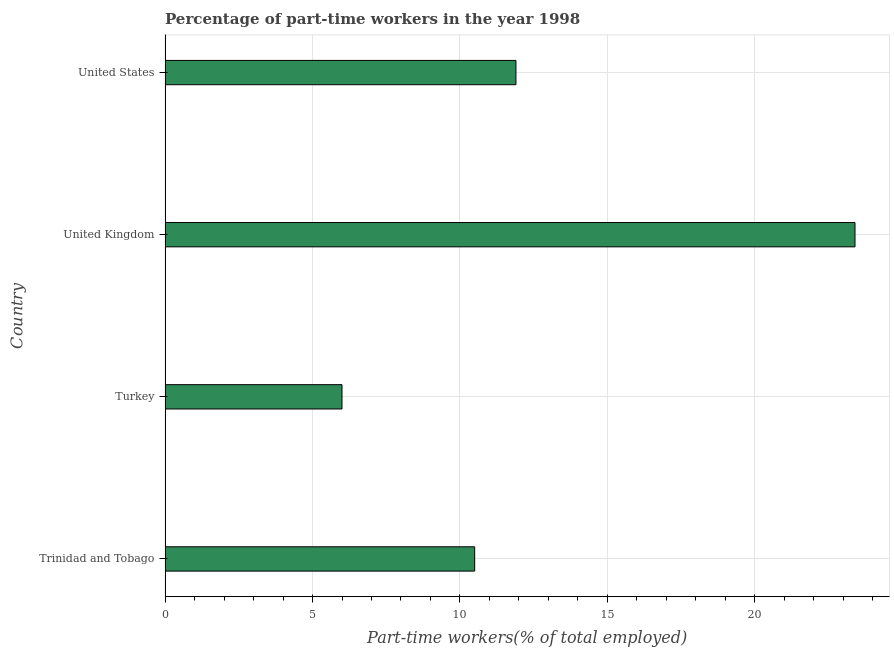What is the title of the graph?
Make the answer very short. Percentage of part-time workers in the year 1998. What is the label or title of the X-axis?
Ensure brevity in your answer.  Part-time workers(% of total employed). What is the label or title of the Y-axis?
Ensure brevity in your answer.  Country. Across all countries, what is the maximum percentage of part-time workers?
Your answer should be very brief. 23.4. Across all countries, what is the minimum percentage of part-time workers?
Your answer should be very brief. 6. In which country was the percentage of part-time workers minimum?
Your answer should be compact. Turkey. What is the sum of the percentage of part-time workers?
Your answer should be compact. 51.8. What is the difference between the percentage of part-time workers in United Kingdom and United States?
Your answer should be very brief. 11.5. What is the average percentage of part-time workers per country?
Provide a succinct answer. 12.95. What is the median percentage of part-time workers?
Offer a very short reply. 11.2. In how many countries, is the percentage of part-time workers greater than 14 %?
Your answer should be very brief. 1. What is the ratio of the percentage of part-time workers in United Kingdom to that in United States?
Your answer should be very brief. 1.97. What is the difference between the highest and the lowest percentage of part-time workers?
Your answer should be very brief. 17.4. In how many countries, is the percentage of part-time workers greater than the average percentage of part-time workers taken over all countries?
Your answer should be compact. 1. How many bars are there?
Offer a very short reply. 4. Are all the bars in the graph horizontal?
Ensure brevity in your answer.  Yes. What is the difference between two consecutive major ticks on the X-axis?
Provide a short and direct response. 5. Are the values on the major ticks of X-axis written in scientific E-notation?
Give a very brief answer. No. What is the Part-time workers(% of total employed) of Trinidad and Tobago?
Keep it short and to the point. 10.5. What is the Part-time workers(% of total employed) of Turkey?
Provide a short and direct response. 6. What is the Part-time workers(% of total employed) in United Kingdom?
Your response must be concise. 23.4. What is the Part-time workers(% of total employed) of United States?
Make the answer very short. 11.9. What is the difference between the Part-time workers(% of total employed) in Trinidad and Tobago and Turkey?
Keep it short and to the point. 4.5. What is the difference between the Part-time workers(% of total employed) in Trinidad and Tobago and United States?
Make the answer very short. -1.4. What is the difference between the Part-time workers(% of total employed) in Turkey and United Kingdom?
Provide a short and direct response. -17.4. What is the difference between the Part-time workers(% of total employed) in Turkey and United States?
Your response must be concise. -5.9. What is the ratio of the Part-time workers(% of total employed) in Trinidad and Tobago to that in United Kingdom?
Keep it short and to the point. 0.45. What is the ratio of the Part-time workers(% of total employed) in Trinidad and Tobago to that in United States?
Offer a very short reply. 0.88. What is the ratio of the Part-time workers(% of total employed) in Turkey to that in United Kingdom?
Your answer should be very brief. 0.26. What is the ratio of the Part-time workers(% of total employed) in Turkey to that in United States?
Offer a terse response. 0.5. What is the ratio of the Part-time workers(% of total employed) in United Kingdom to that in United States?
Your response must be concise. 1.97. 